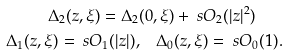Convert formula to latex. <formula><loc_0><loc_0><loc_500><loc_500>\Delta _ { 2 } ( z , \xi ) = \Delta _ { 2 } & ( 0 , \xi ) + \ s O _ { 2 } ( | z | ^ { 2 } ) \\ \Delta _ { 1 } ( z , \xi ) = \ s O _ { 1 } ( | z | ) , & \quad \Delta _ { 0 } ( z , \xi ) = \ s O _ { 0 } ( 1 ) .</formula> 